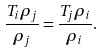Convert formula to latex. <formula><loc_0><loc_0><loc_500><loc_500>\frac { T _ { i } \rho _ { j } } { \rho _ { j } } = \frac { T _ { j } \rho _ { i } } { \rho _ { i } } .</formula> 